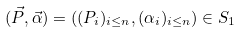Convert formula to latex. <formula><loc_0><loc_0><loc_500><loc_500>( \vec { P } , \vec { \alpha } ) = ( ( P _ { i } ) _ { i \leq n } , ( \alpha _ { i } ) _ { i \leq n } ) \in S _ { 1 }</formula> 